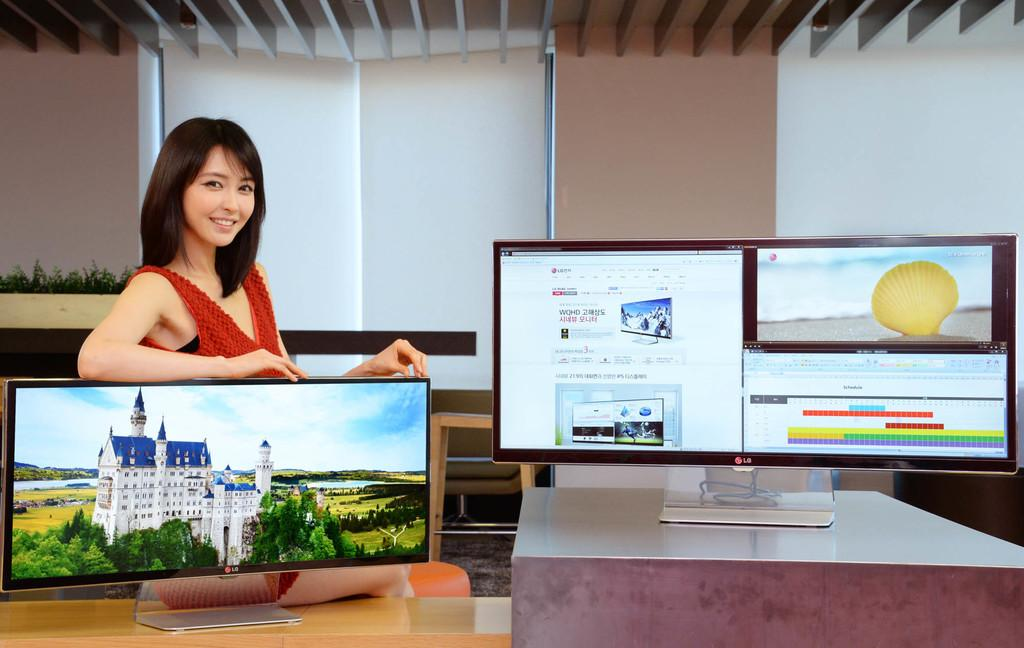How many screens are visible in the image? There are two screens in the image. What is the position of the person in the image? A person is standing behind the left screen. What can be seen behind the person? There is a wall behind the person. How much money is being exchanged between the person and the wall in the image? There is no money being exchanged in the image, as the person is standing behind a screen and there is a wall behind them. What type of rail is present in the image? There is no rail present in the image; it only features two screens and a person standing behind one of them. 